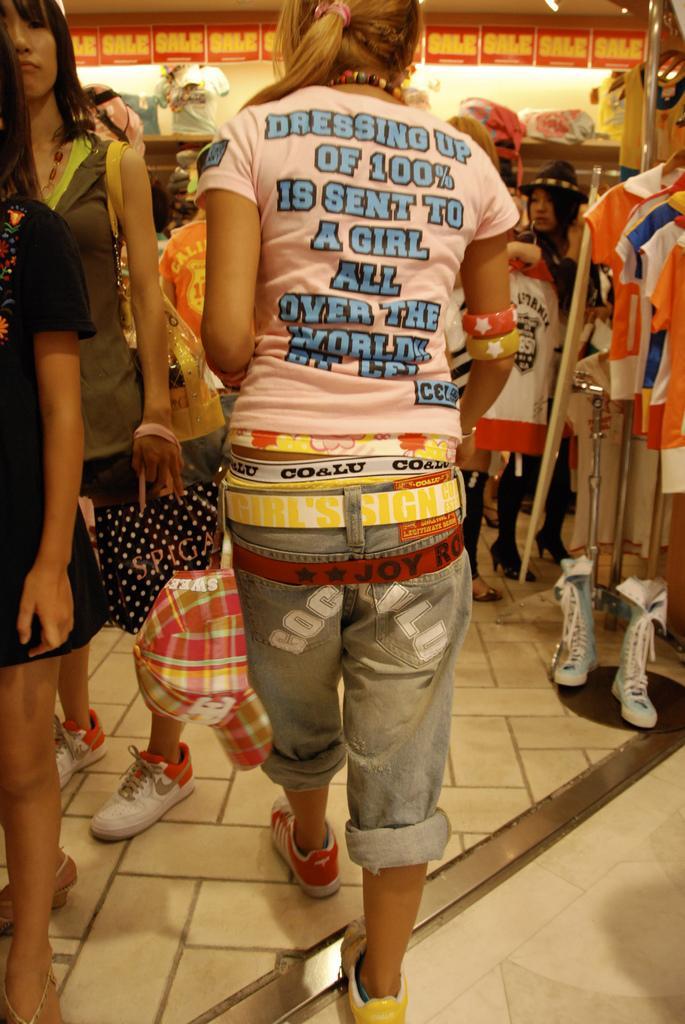Can you describe this image briefly? In this picture we can see a woman wearing a pink t-shirt walking in the cloth store. Behind there are some people and on the right corner we can see some clothes on the stand.  